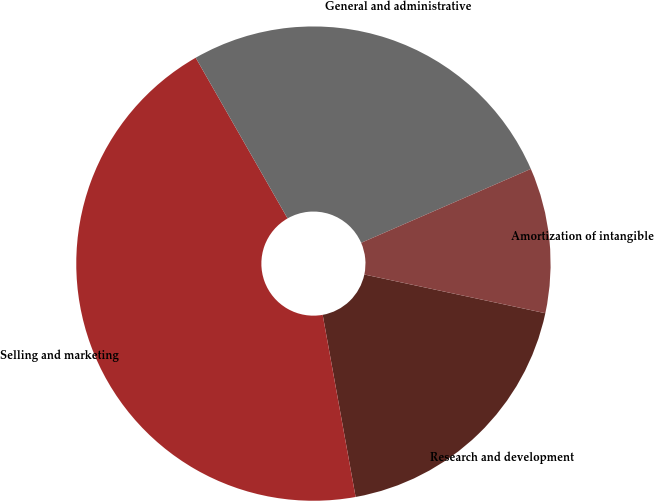Convert chart. <chart><loc_0><loc_0><loc_500><loc_500><pie_chart><fcel>Research and development<fcel>Selling and marketing<fcel>General and administrative<fcel>Amortization of intangible<nl><fcel>18.8%<fcel>44.58%<fcel>26.73%<fcel>9.89%<nl></chart> 